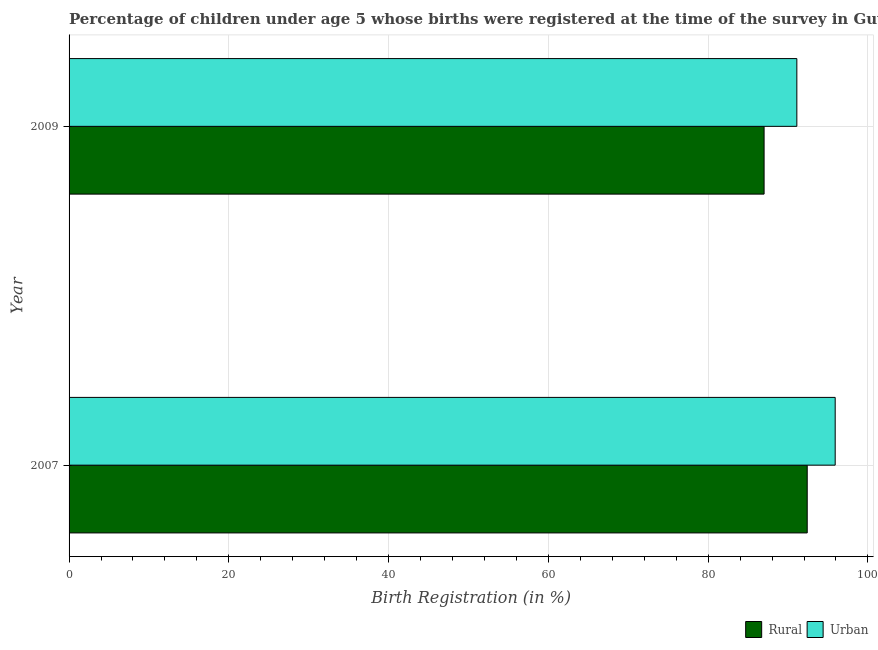How many different coloured bars are there?
Your answer should be very brief. 2. Are the number of bars on each tick of the Y-axis equal?
Offer a terse response. Yes. How many bars are there on the 1st tick from the bottom?
Offer a terse response. 2. What is the label of the 2nd group of bars from the top?
Your response must be concise. 2007. In how many cases, is the number of bars for a given year not equal to the number of legend labels?
Offer a terse response. 0. What is the rural birth registration in 2007?
Your response must be concise. 92.4. Across all years, what is the maximum rural birth registration?
Your response must be concise. 92.4. In which year was the urban birth registration maximum?
Your answer should be compact. 2007. In which year was the urban birth registration minimum?
Make the answer very short. 2009. What is the total rural birth registration in the graph?
Give a very brief answer. 179.4. What is the difference between the rural birth registration in 2009 and the urban birth registration in 2007?
Offer a very short reply. -8.9. What is the average rural birth registration per year?
Offer a terse response. 89.7. What is the ratio of the rural birth registration in 2007 to that in 2009?
Give a very brief answer. 1.06. In how many years, is the urban birth registration greater than the average urban birth registration taken over all years?
Your response must be concise. 1. What does the 1st bar from the top in 2009 represents?
Make the answer very short. Urban. What does the 1st bar from the bottom in 2009 represents?
Make the answer very short. Rural. How many bars are there?
Your answer should be compact. 4. Are all the bars in the graph horizontal?
Provide a succinct answer. Yes. How many years are there in the graph?
Your response must be concise. 2. What is the difference between two consecutive major ticks on the X-axis?
Ensure brevity in your answer.  20. Are the values on the major ticks of X-axis written in scientific E-notation?
Ensure brevity in your answer.  No. Does the graph contain grids?
Your answer should be compact. Yes. Where does the legend appear in the graph?
Provide a succinct answer. Bottom right. How are the legend labels stacked?
Keep it short and to the point. Horizontal. What is the title of the graph?
Ensure brevity in your answer.  Percentage of children under age 5 whose births were registered at the time of the survey in Guyana. Does "Automatic Teller Machines" appear as one of the legend labels in the graph?
Your answer should be compact. No. What is the label or title of the X-axis?
Your response must be concise. Birth Registration (in %). What is the label or title of the Y-axis?
Give a very brief answer. Year. What is the Birth Registration (in %) of Rural in 2007?
Give a very brief answer. 92.4. What is the Birth Registration (in %) in Urban in 2007?
Provide a short and direct response. 95.9. What is the Birth Registration (in %) of Urban in 2009?
Provide a succinct answer. 91.1. Across all years, what is the maximum Birth Registration (in %) of Rural?
Ensure brevity in your answer.  92.4. Across all years, what is the maximum Birth Registration (in %) of Urban?
Make the answer very short. 95.9. Across all years, what is the minimum Birth Registration (in %) of Rural?
Ensure brevity in your answer.  87. Across all years, what is the minimum Birth Registration (in %) in Urban?
Offer a terse response. 91.1. What is the total Birth Registration (in %) of Rural in the graph?
Make the answer very short. 179.4. What is the total Birth Registration (in %) in Urban in the graph?
Provide a succinct answer. 187. What is the difference between the Birth Registration (in %) in Rural in 2007 and that in 2009?
Your answer should be very brief. 5.4. What is the difference between the Birth Registration (in %) of Urban in 2007 and that in 2009?
Keep it short and to the point. 4.8. What is the average Birth Registration (in %) in Rural per year?
Offer a very short reply. 89.7. What is the average Birth Registration (in %) of Urban per year?
Make the answer very short. 93.5. What is the ratio of the Birth Registration (in %) of Rural in 2007 to that in 2009?
Ensure brevity in your answer.  1.06. What is the ratio of the Birth Registration (in %) of Urban in 2007 to that in 2009?
Offer a very short reply. 1.05. What is the difference between the highest and the lowest Birth Registration (in %) in Rural?
Provide a succinct answer. 5.4. 